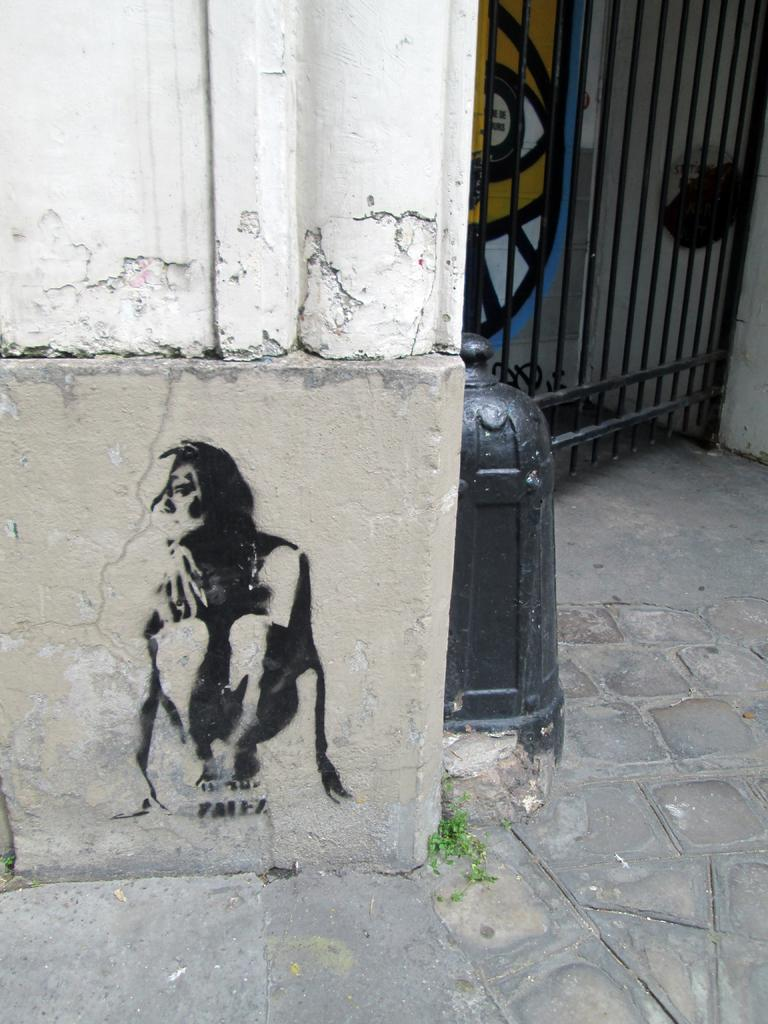What is depicted on the wall in the image? There is a sketch on the wall in the image. What can be seen on the right side of the image? There is a gate on the right side of the image. What is the comfort level of the form in the image? There is no form present in the image, only a sketch on the wall and a gate on the right side. 